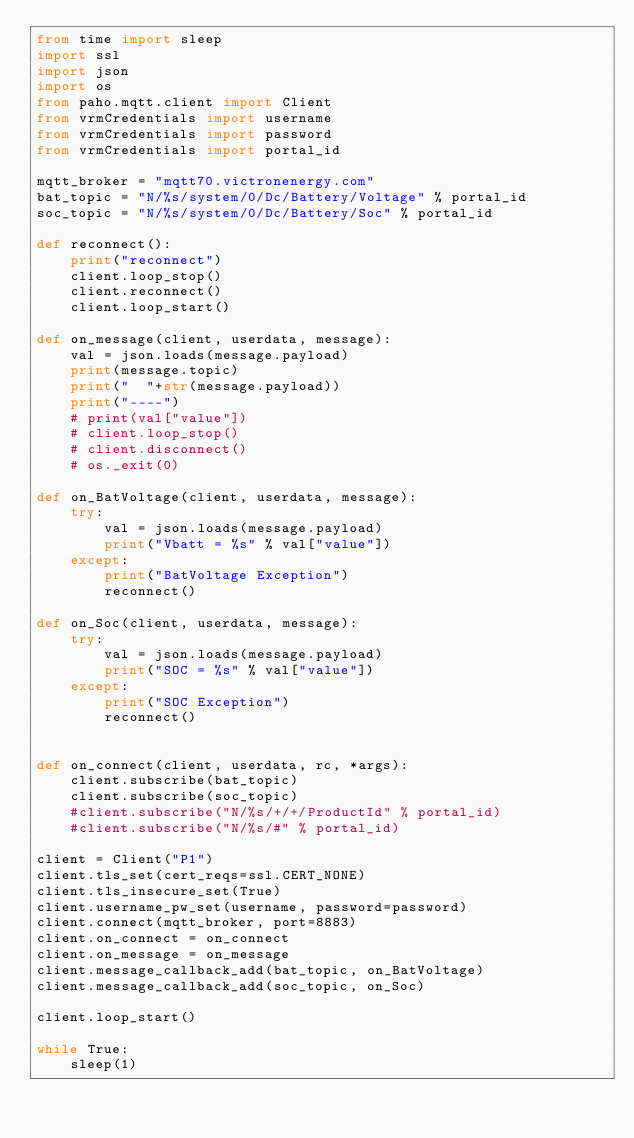<code> <loc_0><loc_0><loc_500><loc_500><_Python_>from time import sleep
import ssl
import json
import os
from paho.mqtt.client import Client 
from vrmCredentials import username
from vrmCredentials import password
from vrmCredentials import portal_id
 
mqtt_broker = "mqtt70.victronenergy.com"
bat_topic = "N/%s/system/0/Dc/Battery/Voltage" % portal_id
soc_topic = "N/%s/system/0/Dc/Battery/Soc" % portal_id

def reconnect():
    print("reconnect")
    client.loop_stop()
    client.reconnect()
    client.loop_start()
 
def on_message(client, userdata, message):
    val = json.loads(message.payload)
    print(message.topic)
    print("  "+str(message.payload))
    print("----")
    # print(val["value"])
    # client.loop_stop()
    # client.disconnect()
    # os._exit(0)

def on_BatVoltage(client, userdata, message):
    try:
        val = json.loads(message.payload)
        print("Vbatt = %s" % val["value"])
    except:
        print("BatVoltage Exception")
        reconnect()
 
def on_Soc(client, userdata, message):
    try:
        val = json.loads(message.payload)
        print("SOC = %s" % val["value"])
    except:
        print("SOC Exception")
        reconnect()
 
 
def on_connect(client, userdata, rc, *args): 
    client.subscribe(bat_topic)
    client.subscribe(soc_topic)
    #client.subscribe("N/%s/+/+/ProductId" % portal_id)
    #client.subscribe("N/%s/#" % portal_id)
 
client = Client("P1")
client.tls_set(cert_reqs=ssl.CERT_NONE)
client.tls_insecure_set(True)
client.username_pw_set(username, password=password)
client.connect(mqtt_broker, port=8883)
client.on_connect = on_connect
client.on_message = on_message
client.message_callback_add(bat_topic, on_BatVoltage)
client.message_callback_add(soc_topic, on_Soc)
 
client.loop_start()
 
while True:
    sleep(1)

</code> 